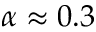Convert formula to latex. <formula><loc_0><loc_0><loc_500><loc_500>\alpha \approx 0 . 3</formula> 